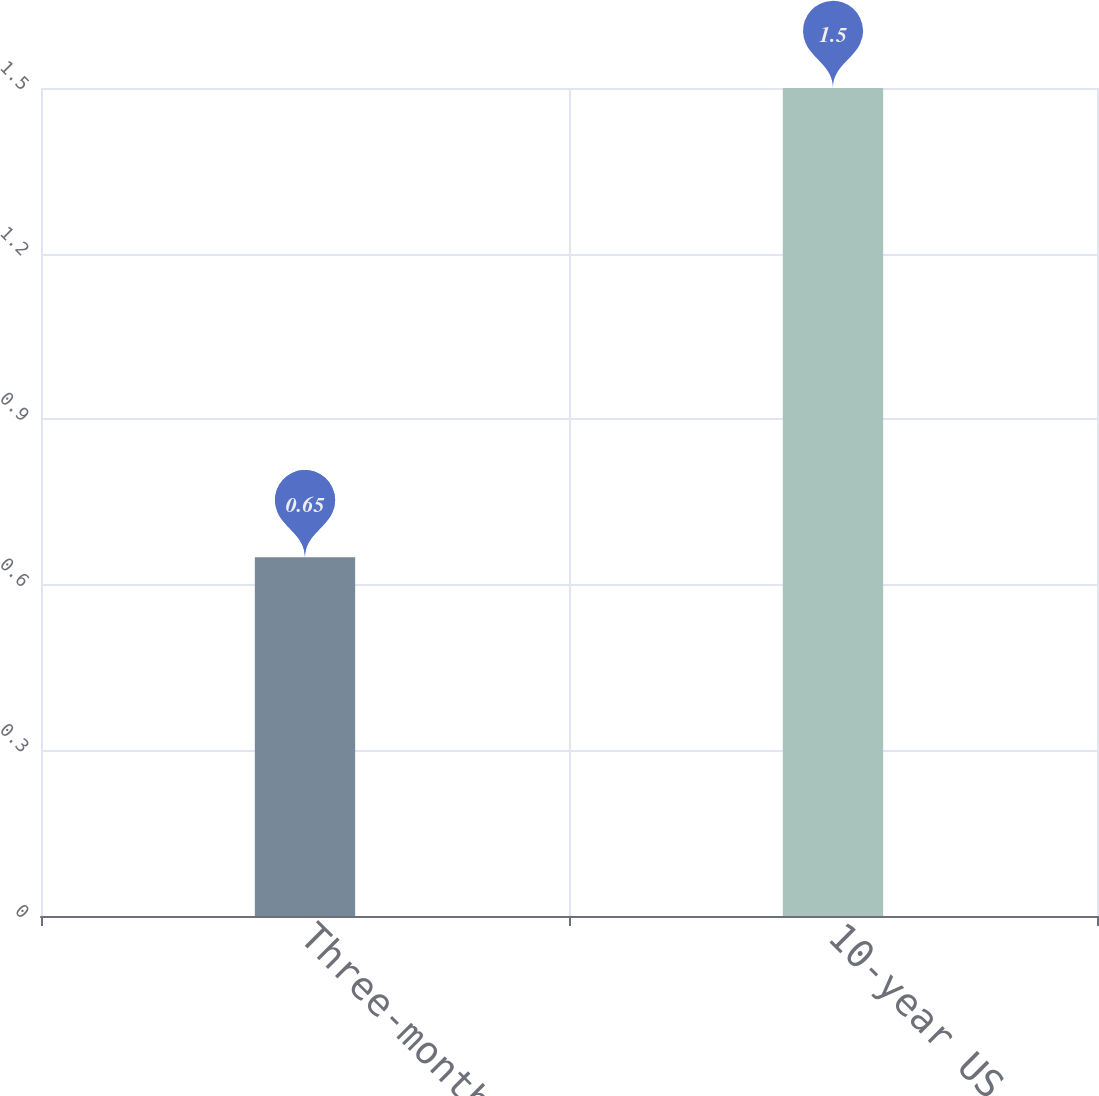Convert chart to OTSL. <chart><loc_0><loc_0><loc_500><loc_500><bar_chart><fcel>Three-month LIBOR<fcel>10-year US Treasury<nl><fcel>0.65<fcel>1.5<nl></chart> 